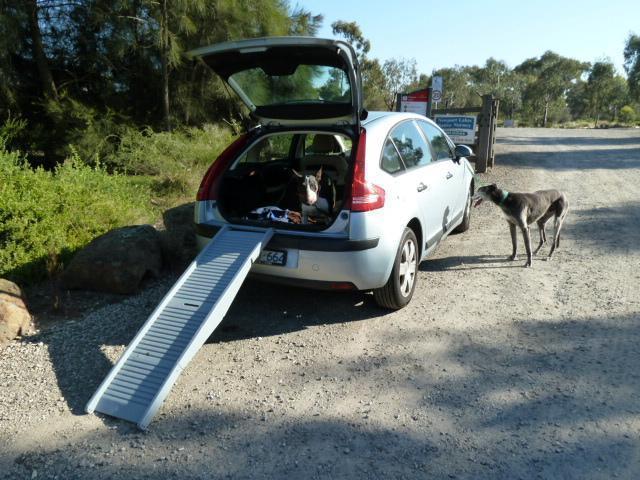What uses the ramp on the back of the car?
Indicate the correct choice and explain in the format: 'Answer: answer
Rationale: rationale.'
Options: Birds, cats, babies, dogs. Answer: dogs.
Rationale: This is used when they get old and can't jump up anymore 